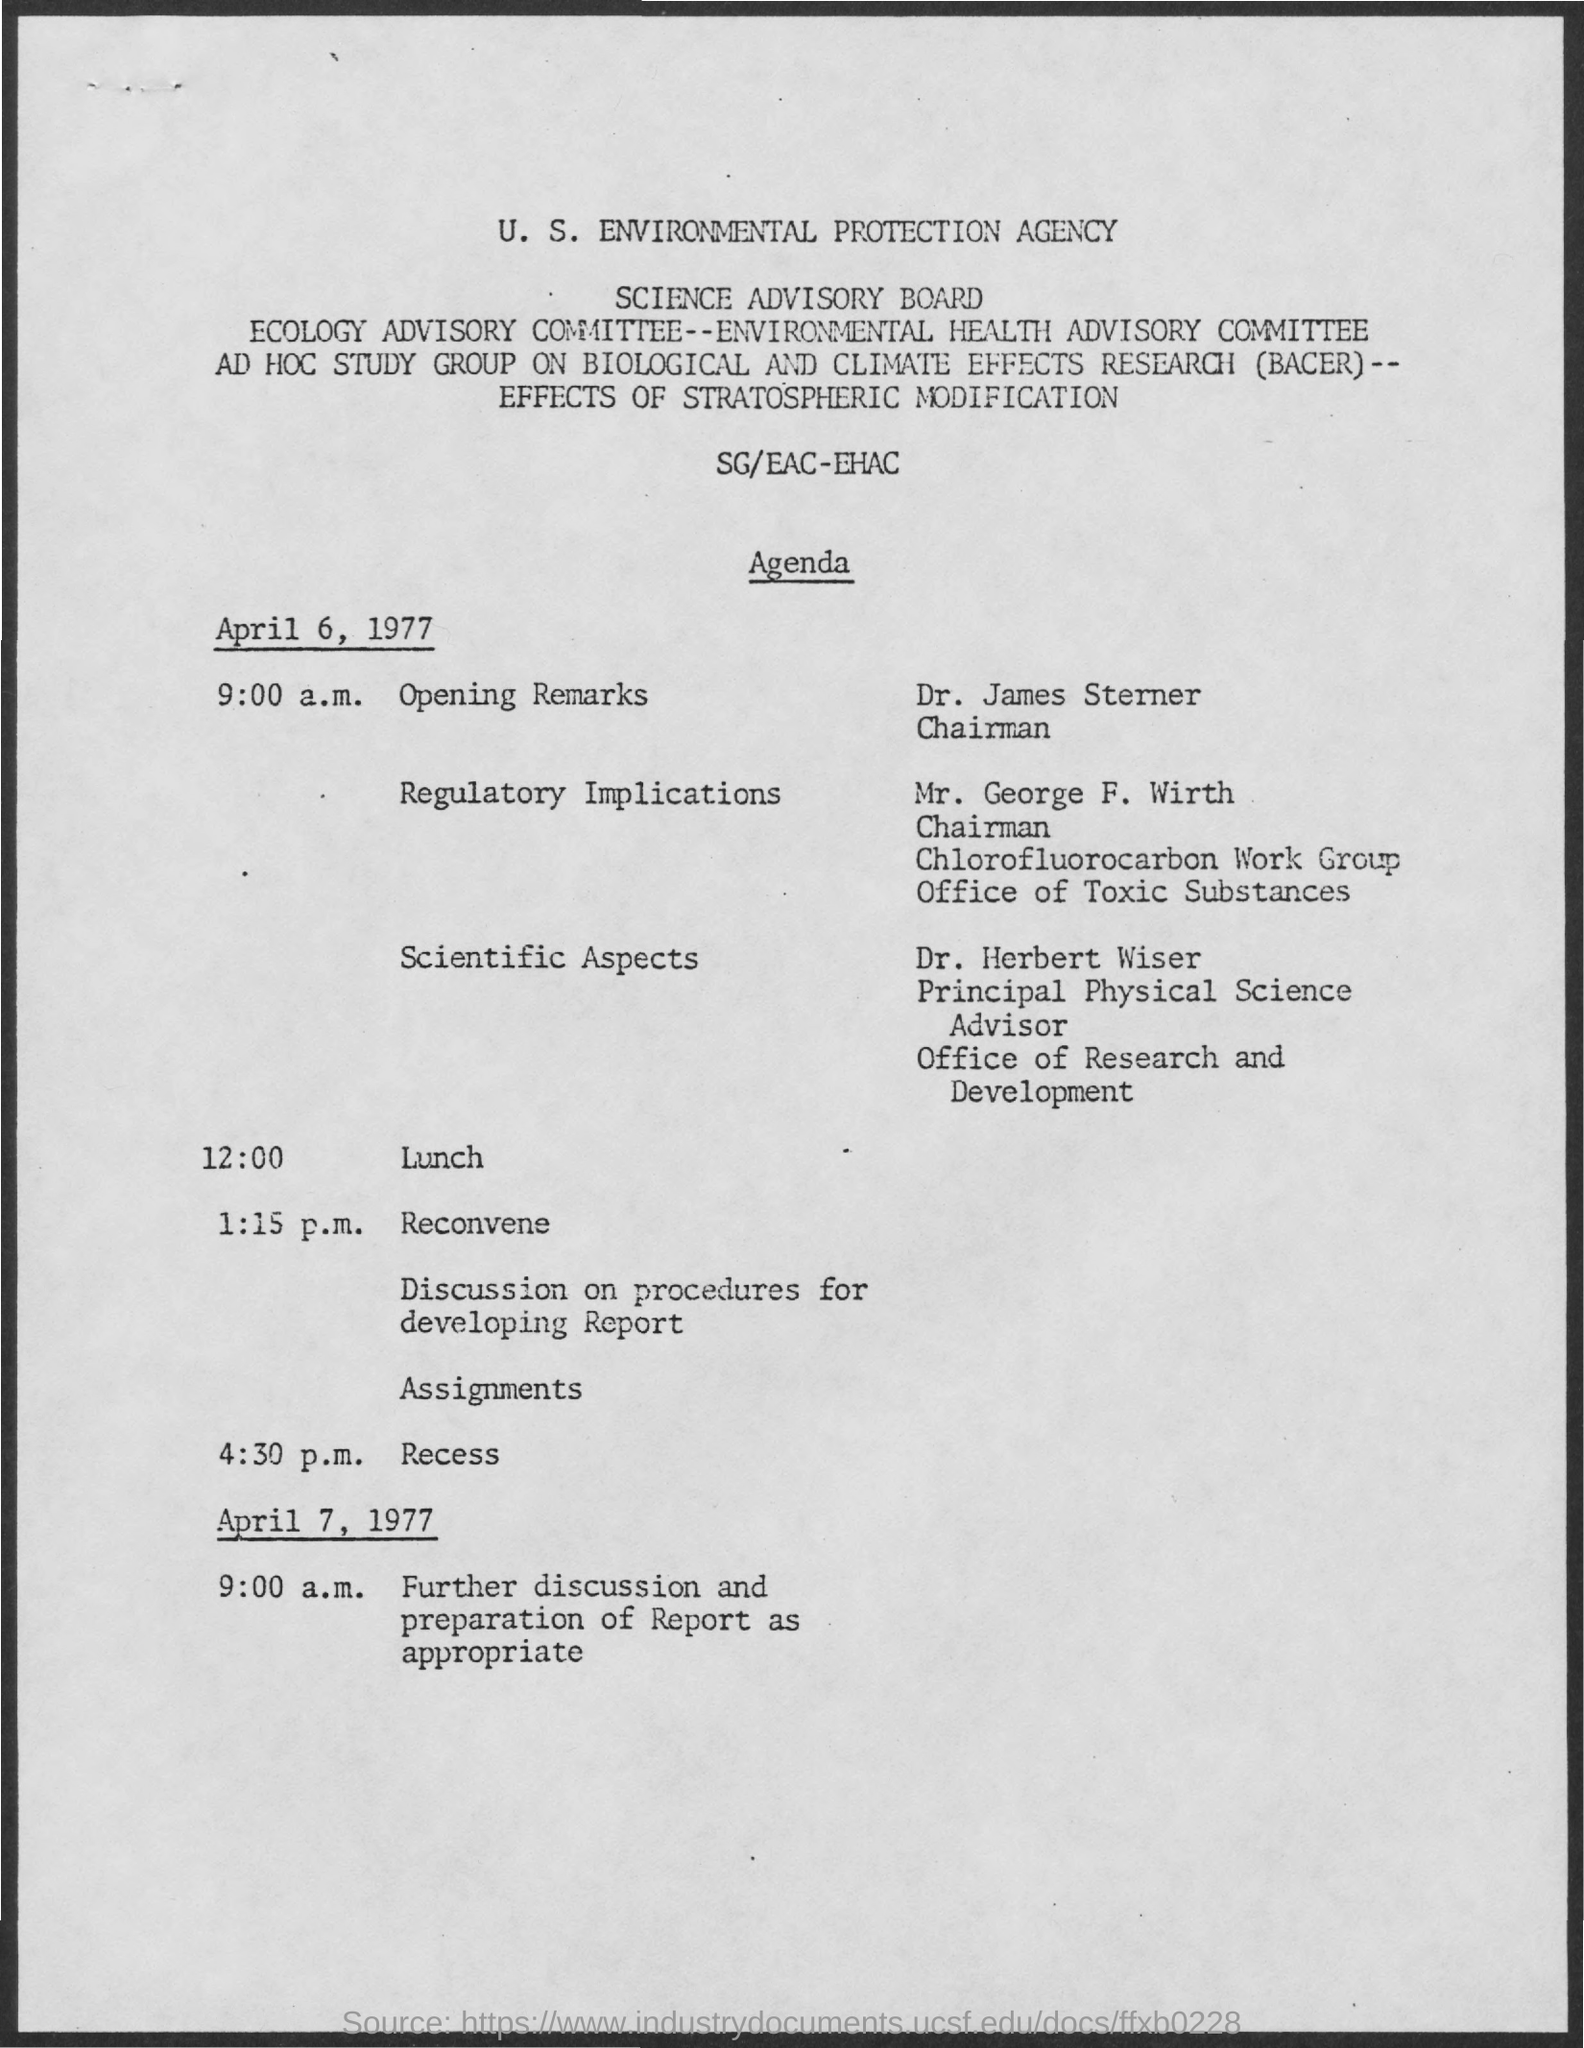Outline some significant characteristics in this image. The schedule at the time of 12:00 pm is lunch. The acronym "BACER" stands for "Biological and Climate Effects Research. The Science Advisory Board is a board mentioned in the given page. At 9:00 a.m. on April 6, 1977, the schedule included opening remarks. 